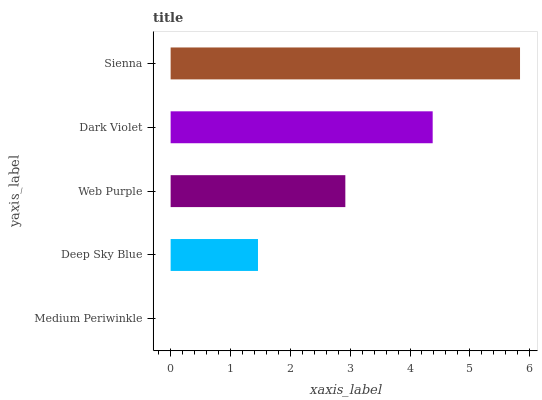Is Medium Periwinkle the minimum?
Answer yes or no. Yes. Is Sienna the maximum?
Answer yes or no. Yes. Is Deep Sky Blue the minimum?
Answer yes or no. No. Is Deep Sky Blue the maximum?
Answer yes or no. No. Is Deep Sky Blue greater than Medium Periwinkle?
Answer yes or no. Yes. Is Medium Periwinkle less than Deep Sky Blue?
Answer yes or no. Yes. Is Medium Periwinkle greater than Deep Sky Blue?
Answer yes or no. No. Is Deep Sky Blue less than Medium Periwinkle?
Answer yes or no. No. Is Web Purple the high median?
Answer yes or no. Yes. Is Web Purple the low median?
Answer yes or no. Yes. Is Dark Violet the high median?
Answer yes or no. No. Is Deep Sky Blue the low median?
Answer yes or no. No. 